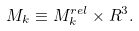<formula> <loc_0><loc_0><loc_500><loc_500>M _ { k } \equiv M _ { k } ^ { r e l } \times R ^ { 3 } .</formula> 